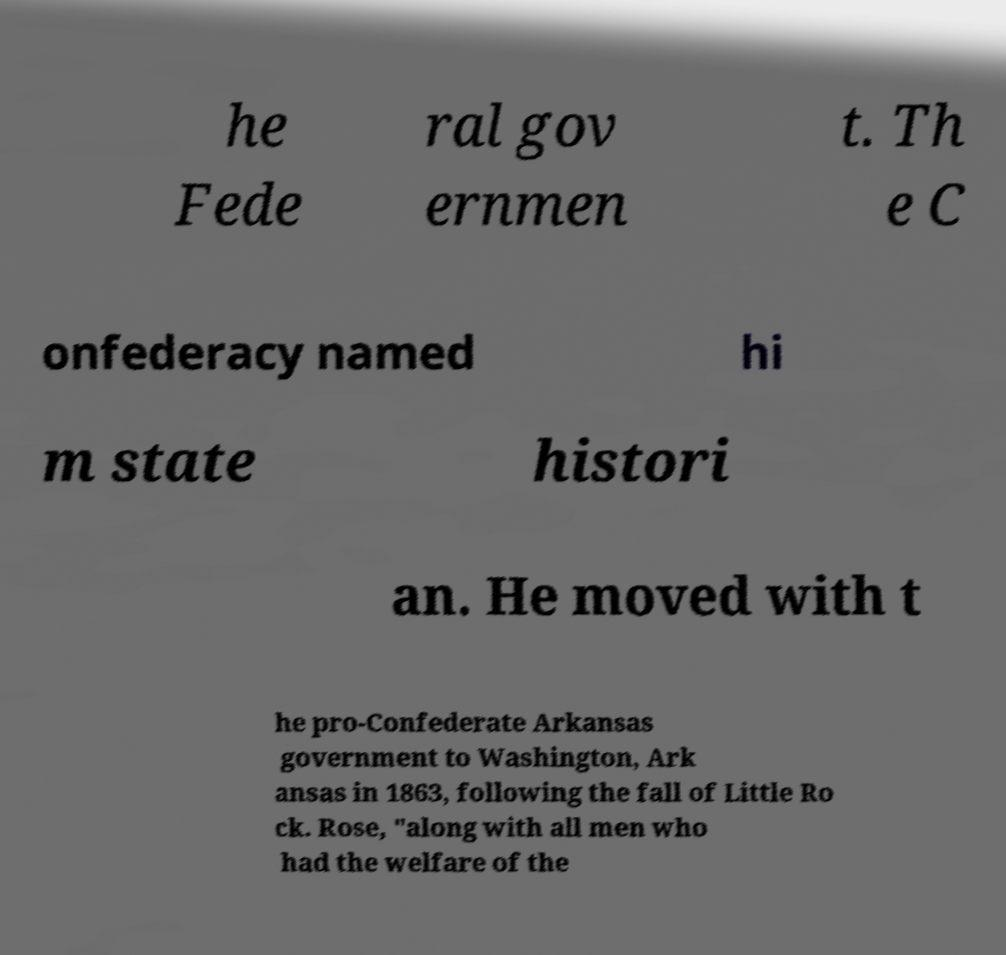I need the written content from this picture converted into text. Can you do that? he Fede ral gov ernmen t. Th e C onfederacy named hi m state histori an. He moved with t he pro-Confederate Arkansas government to Washington, Ark ansas in 1863, following the fall of Little Ro ck. Rose, "along with all men who had the welfare of the 